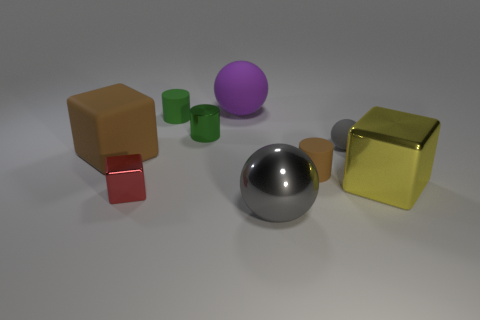The small matte object that is the same color as the big matte cube is what shape?
Provide a short and direct response. Cylinder. How big is the object that is left of the big gray thing and in front of the large yellow thing?
Your answer should be very brief. Small. How many yellow rubber cubes are there?
Make the answer very short. 0. How many balls are either green metallic things or green rubber objects?
Ensure brevity in your answer.  0. What number of brown blocks are on the right side of the gray sphere that is in front of the cylinder right of the big purple ball?
Offer a very short reply. 0. What color is the metal ball that is the same size as the brown matte block?
Provide a short and direct response. Gray. What number of other objects are the same color as the rubber block?
Offer a very short reply. 1. Is the number of big balls behind the green rubber cylinder greater than the number of large purple balls?
Provide a succinct answer. No. Is the material of the purple thing the same as the small block?
Offer a very short reply. No. How many objects are brown matte things to the right of the red metallic block or large gray objects?
Provide a succinct answer. 2. 